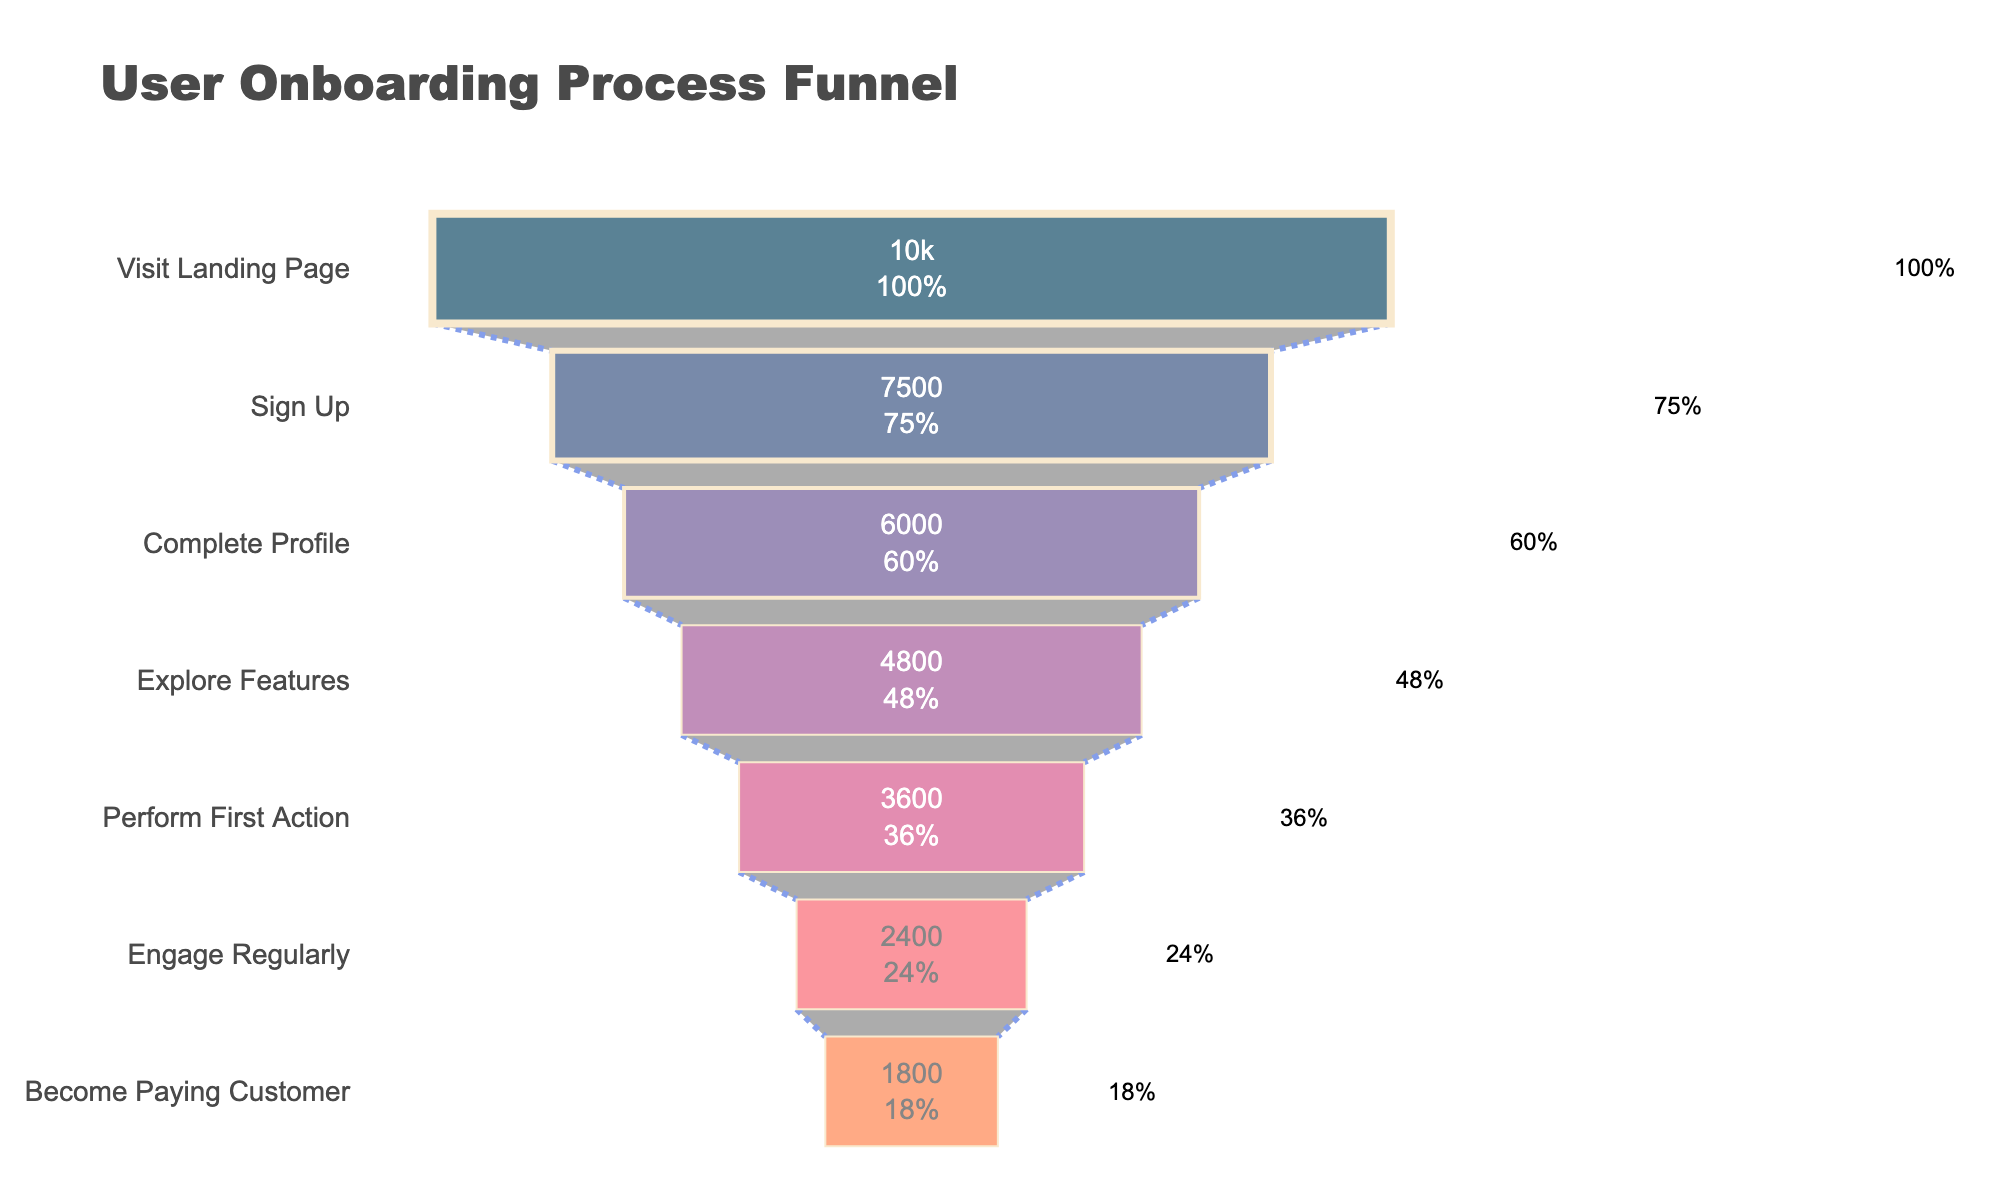What's the title of the figure? The title of the figure is the text at the top, which gives a summary of the content. The title is "User Onboarding Process Funnel".
Answer: User Onboarding Process Funnel What is the percentage of users who sign up after visiting the landing page? This is shown in the funnel chart where the percentage is next to the "Sign Up" stage text, indicating how many users completed that stage compared to the initial stage. It is 75%.
Answer: 75% By how many users did the total count drop from "Complete Profile" to "Explore Features"? You need to find the number of users at both stages and then subtract the latter from the former. The number of users dropped from 6000 (Complete Profile) to 4800 (Explore Features), the difference is 6000 - 4800 = 1200.
Answer: 1200 What percentage of users become paying customers by the end of the funnel? The final stage in the funnel is "Become Paying Customer," and the percentage next to it represents the portion of users remaining by the end of the onboarding process. The percentage shown is 18%.
Answer: 18% Which stage has the largest drop-off in user counts? To determine the largest drop-off, look at the change in user numbers between stages. From "Engage Regularly" (2400 users) to "Become Paying Customer" (1800 users) the drop-off is the largest at 600 users (2400 - 1800).
Answer: Engage Regularly to Become Paying Customer What is the total percentage decrease from "Explore Features" to "Engage Regularly"? To calculate this, you can subtract the percentage at "Engage Regularly" from that at "Explore Features". The percentage at "Explore Features" is 48% and at "Engage Regularly" it is 24%. The decrease is 48% - 24% = 24%.
Answer: 24% How many users complete their profile after signing up? The number of users at the "Complete Profile" stage indicates how many moved on from the "Sign Up" stage. The number is 6000 users.
Answer: 6000 Compare the number of users that perform the first action to those who sign up. Which is larger and by how much? The "Sign Up" stage has 7500 users and "Perform First Action" has 3600 users. To compare, subtract the smaller from the larger number. 7500 (Sign Up) - 3600 (Perform First Action) = 3900. Thus, "Sign Up" is larger by 3900.
Answer: Sign Up by 3900 Between which stages does the smallest drop-off occur? By examining the user numbers between each stage, the smallest difference occurs between "Complete Profile" (6000) and "Explore Features" (4800), which is a difference of 1200.
Answer: Complete Profile to Explore Features If the number of users who visit the landing page is doubled, what would be the new number of paying customers assuming the percentages remain constant? Doubling the initial number of users visiting the landing page from 10000 to 20000, and maintaining the final conversion percentage (18%), the number of paying customers would be 20000 * 0.18 = 3600.
Answer: 3600 